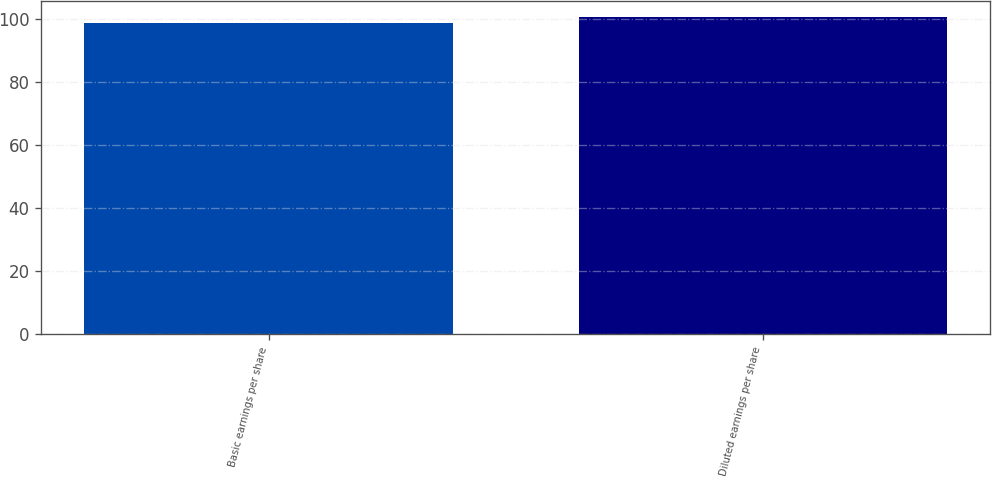Convert chart to OTSL. <chart><loc_0><loc_0><loc_500><loc_500><bar_chart><fcel>Basic earnings per share<fcel>Diluted earnings per share<nl><fcel>98.8<fcel>100.6<nl></chart> 